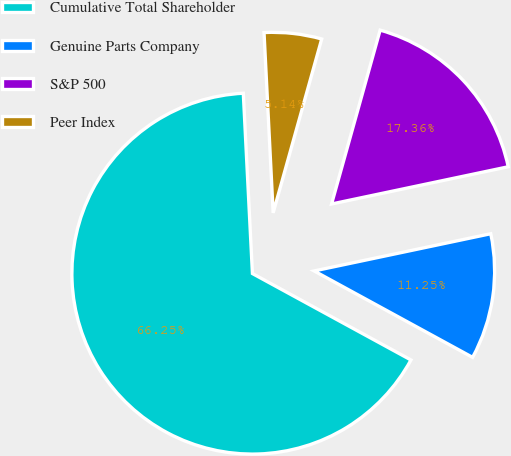Convert chart to OTSL. <chart><loc_0><loc_0><loc_500><loc_500><pie_chart><fcel>Cumulative Total Shareholder<fcel>Genuine Parts Company<fcel>S&P 500<fcel>Peer Index<nl><fcel>66.25%<fcel>11.25%<fcel>17.36%<fcel>5.14%<nl></chart> 